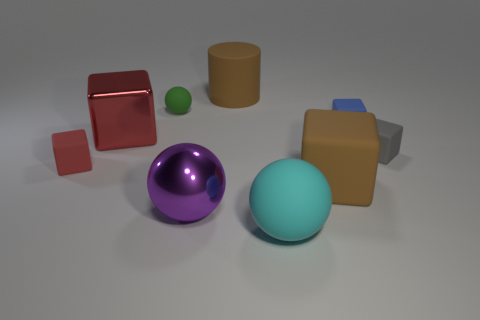There is a red thing in front of the large metal cube; is it the same size as the brown rubber thing that is on the right side of the cyan rubber sphere?
Your answer should be very brief. No. Do the purple object and the big ball that is in front of the big purple ball have the same material?
Give a very brief answer. No. Are there more large brown cylinders that are in front of the purple sphere than spheres on the right side of the large metal block?
Your answer should be very brief. No. What color is the matte sphere that is in front of the big metallic object that is left of the tiny green matte thing?
Your response must be concise. Cyan. How many cubes are either red rubber objects or large purple metal objects?
Offer a very short reply. 1. How many matte spheres are both in front of the large rubber cube and behind the large cyan sphere?
Make the answer very short. 0. What is the color of the big cube in front of the small red matte object?
Your response must be concise. Brown. There is a green ball that is the same material as the small blue object; what is its size?
Ensure brevity in your answer.  Small. What number of big red metallic things are behind the brown thing that is behind the small green rubber sphere?
Make the answer very short. 0. There is a big purple metallic sphere; how many rubber blocks are on the right side of it?
Ensure brevity in your answer.  3. 